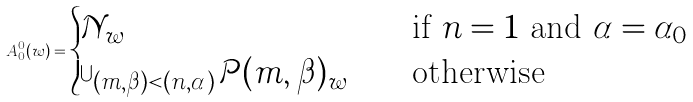Convert formula to latex. <formula><loc_0><loc_0><loc_500><loc_500>A _ { 0 } ^ { 0 } ( w ) = \begin{cases} \mathcal { N } _ { w } & \quad \text {if $n=1$ and $\alpha=\alpha_{0}$} \\ \bigcup _ { ( m , \beta ) < ( n , \alpha ) } \mathcal { P } ( m , \beta ) _ { w } & \quad \text {otherwise} \end{cases}</formula> 